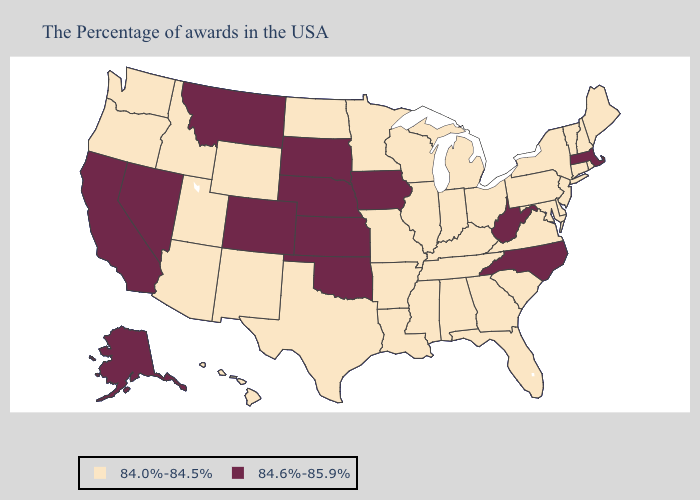Which states have the highest value in the USA?
Short answer required. Massachusetts, North Carolina, West Virginia, Iowa, Kansas, Nebraska, Oklahoma, South Dakota, Colorado, Montana, Nevada, California, Alaska. Which states have the highest value in the USA?
Short answer required. Massachusetts, North Carolina, West Virginia, Iowa, Kansas, Nebraska, Oklahoma, South Dakota, Colorado, Montana, Nevada, California, Alaska. What is the lowest value in states that border Minnesota?
Give a very brief answer. 84.0%-84.5%. What is the lowest value in the Northeast?
Quick response, please. 84.0%-84.5%. Name the states that have a value in the range 84.6%-85.9%?
Be succinct. Massachusetts, North Carolina, West Virginia, Iowa, Kansas, Nebraska, Oklahoma, South Dakota, Colorado, Montana, Nevada, California, Alaska. Does Nevada have the lowest value in the West?
Be succinct. No. Name the states that have a value in the range 84.0%-84.5%?
Concise answer only. Maine, Rhode Island, New Hampshire, Vermont, Connecticut, New York, New Jersey, Delaware, Maryland, Pennsylvania, Virginia, South Carolina, Ohio, Florida, Georgia, Michigan, Kentucky, Indiana, Alabama, Tennessee, Wisconsin, Illinois, Mississippi, Louisiana, Missouri, Arkansas, Minnesota, Texas, North Dakota, Wyoming, New Mexico, Utah, Arizona, Idaho, Washington, Oregon, Hawaii. What is the value of Ohio?
Write a very short answer. 84.0%-84.5%. Does North Dakota have a higher value than Arkansas?
Concise answer only. No. Does Iowa have the same value as West Virginia?
Quick response, please. Yes. What is the value of Arizona?
Give a very brief answer. 84.0%-84.5%. What is the value of Hawaii?
Write a very short answer. 84.0%-84.5%. Name the states that have a value in the range 84.0%-84.5%?
Write a very short answer. Maine, Rhode Island, New Hampshire, Vermont, Connecticut, New York, New Jersey, Delaware, Maryland, Pennsylvania, Virginia, South Carolina, Ohio, Florida, Georgia, Michigan, Kentucky, Indiana, Alabama, Tennessee, Wisconsin, Illinois, Mississippi, Louisiana, Missouri, Arkansas, Minnesota, Texas, North Dakota, Wyoming, New Mexico, Utah, Arizona, Idaho, Washington, Oregon, Hawaii. Name the states that have a value in the range 84.0%-84.5%?
Keep it brief. Maine, Rhode Island, New Hampshire, Vermont, Connecticut, New York, New Jersey, Delaware, Maryland, Pennsylvania, Virginia, South Carolina, Ohio, Florida, Georgia, Michigan, Kentucky, Indiana, Alabama, Tennessee, Wisconsin, Illinois, Mississippi, Louisiana, Missouri, Arkansas, Minnesota, Texas, North Dakota, Wyoming, New Mexico, Utah, Arizona, Idaho, Washington, Oregon, Hawaii. Name the states that have a value in the range 84.0%-84.5%?
Give a very brief answer. Maine, Rhode Island, New Hampshire, Vermont, Connecticut, New York, New Jersey, Delaware, Maryland, Pennsylvania, Virginia, South Carolina, Ohio, Florida, Georgia, Michigan, Kentucky, Indiana, Alabama, Tennessee, Wisconsin, Illinois, Mississippi, Louisiana, Missouri, Arkansas, Minnesota, Texas, North Dakota, Wyoming, New Mexico, Utah, Arizona, Idaho, Washington, Oregon, Hawaii. 